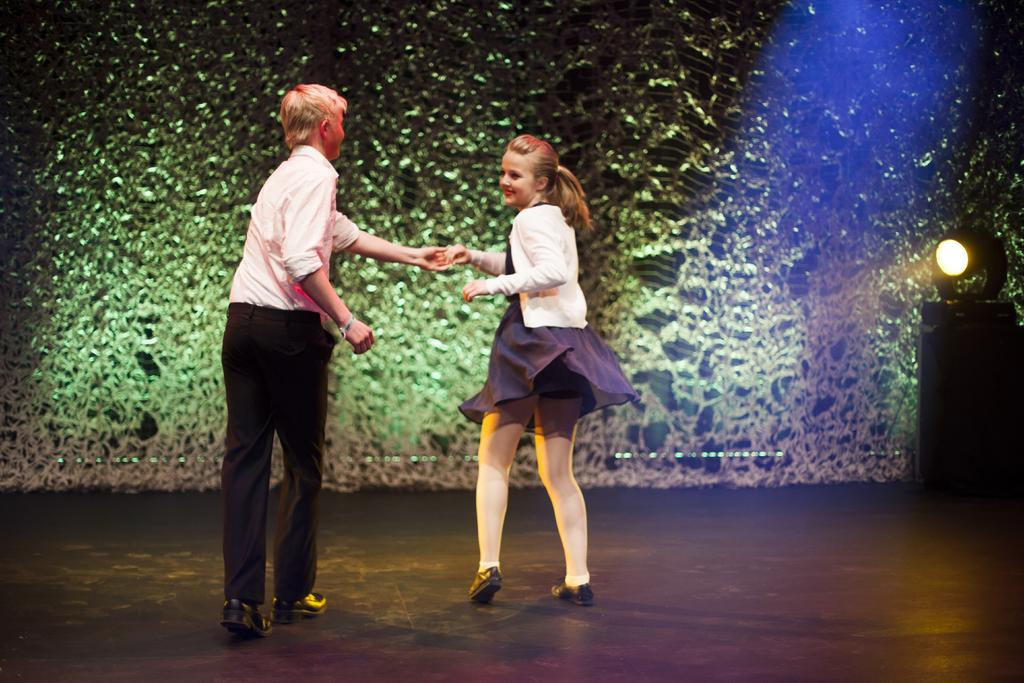What can be seen on the surface in the image? There is a light on the surface in the image. What are the two persons doing in the image? The two persons are dancing on a stage. What is the color and size of the wall behind the persons on the stage? There is a big green color wall behind the persons on the stage. How many rabbits are hopping on the stage in the image? There are no rabbits present in the image; it features two persons dancing on a stage. What type of cracker is being used as a prop by the dancers in the image? There is no cracker present in the image, and the dancers are not using any props. 